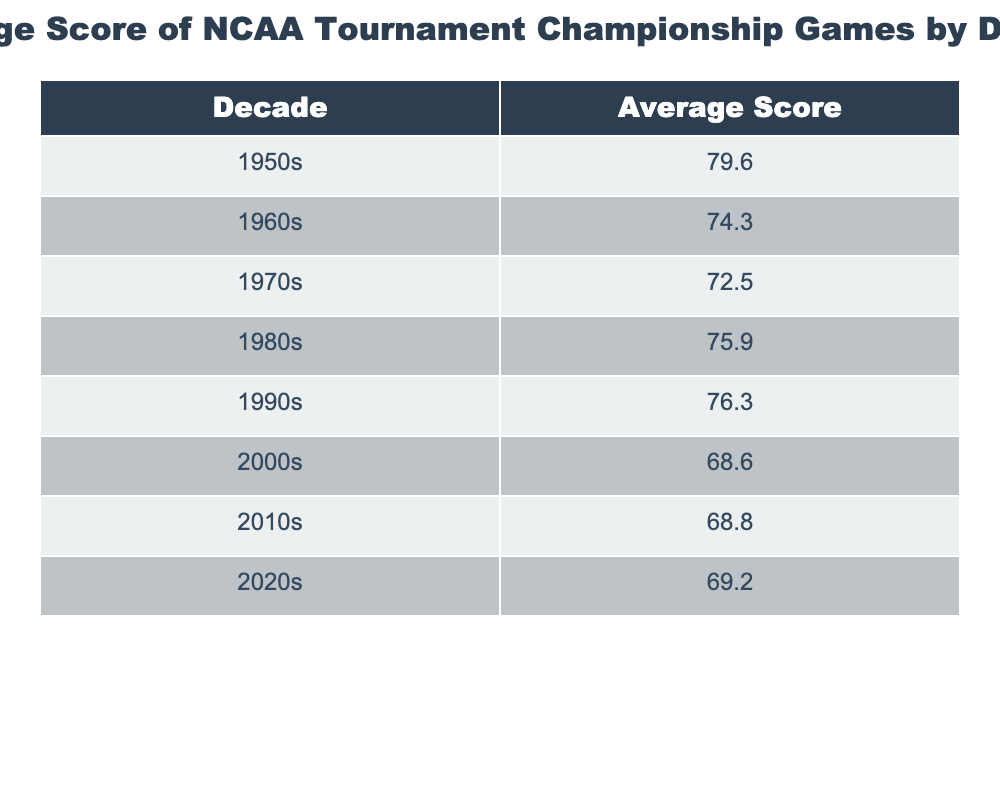What was the average score in the 1950s? The table shows that the average score for the 1950s is directly listed as 79.6.
Answer: 79.6 Which decade had the highest average score? By examining the average scores in the table, the 1950s has the highest average score at 79.6, compared to all other decades.
Answer: 1950s What is the difference in average scores between the 1980s and the 2000s? The average score for the 1980s is 75.9, and for the 2000s is 68.6. The difference is calculated as 75.9 - 68.6 = 7.3.
Answer: 7.3 Is the average score in the 2020s higher than in the 2010s? The average score for the 2020s is 69.2, while for the 2010s it is 68.8. Since 69.2 is greater than 68.8, the statement is true.
Answer: Yes What is the average score of the 1970s and 1980s combined? The average for the 1970s is 72.5 and for the 1980s is 75.9. The sum is 72.5 + 75.9 = 148.4, and to find the average, we divide by 2: 148.4 / 2 = 74.2.
Answer: 74.2 Was there a trend of increasing average scores over the decades? To determine this, we look through each decade: 79.6, 74.3, 72.5, 75.9, 76.3, 68.6, 68.8, and 69.2. Observing these scores clearly indicates a peak and decline followed by slight increases, so it is not a consistent trend.
Answer: No What is the average score across all decades? To calculate the average, we first sum all the scores: 79.6 + 74.3 + 72.5 + 75.9 + 76.3 + 68.6 + 68.8 + 69.2 = 595.2, and then divide by the number of decades (8): 595.2 / 8 = 74.4.
Answer: 74.4 In which two decades did the average scores fall below 70? The table shows that the average scores for the 2000s (68.6) and the 2010s (68.8) are below 70, making them the two decades where this occurs.
Answer: 2000s and 2010s 